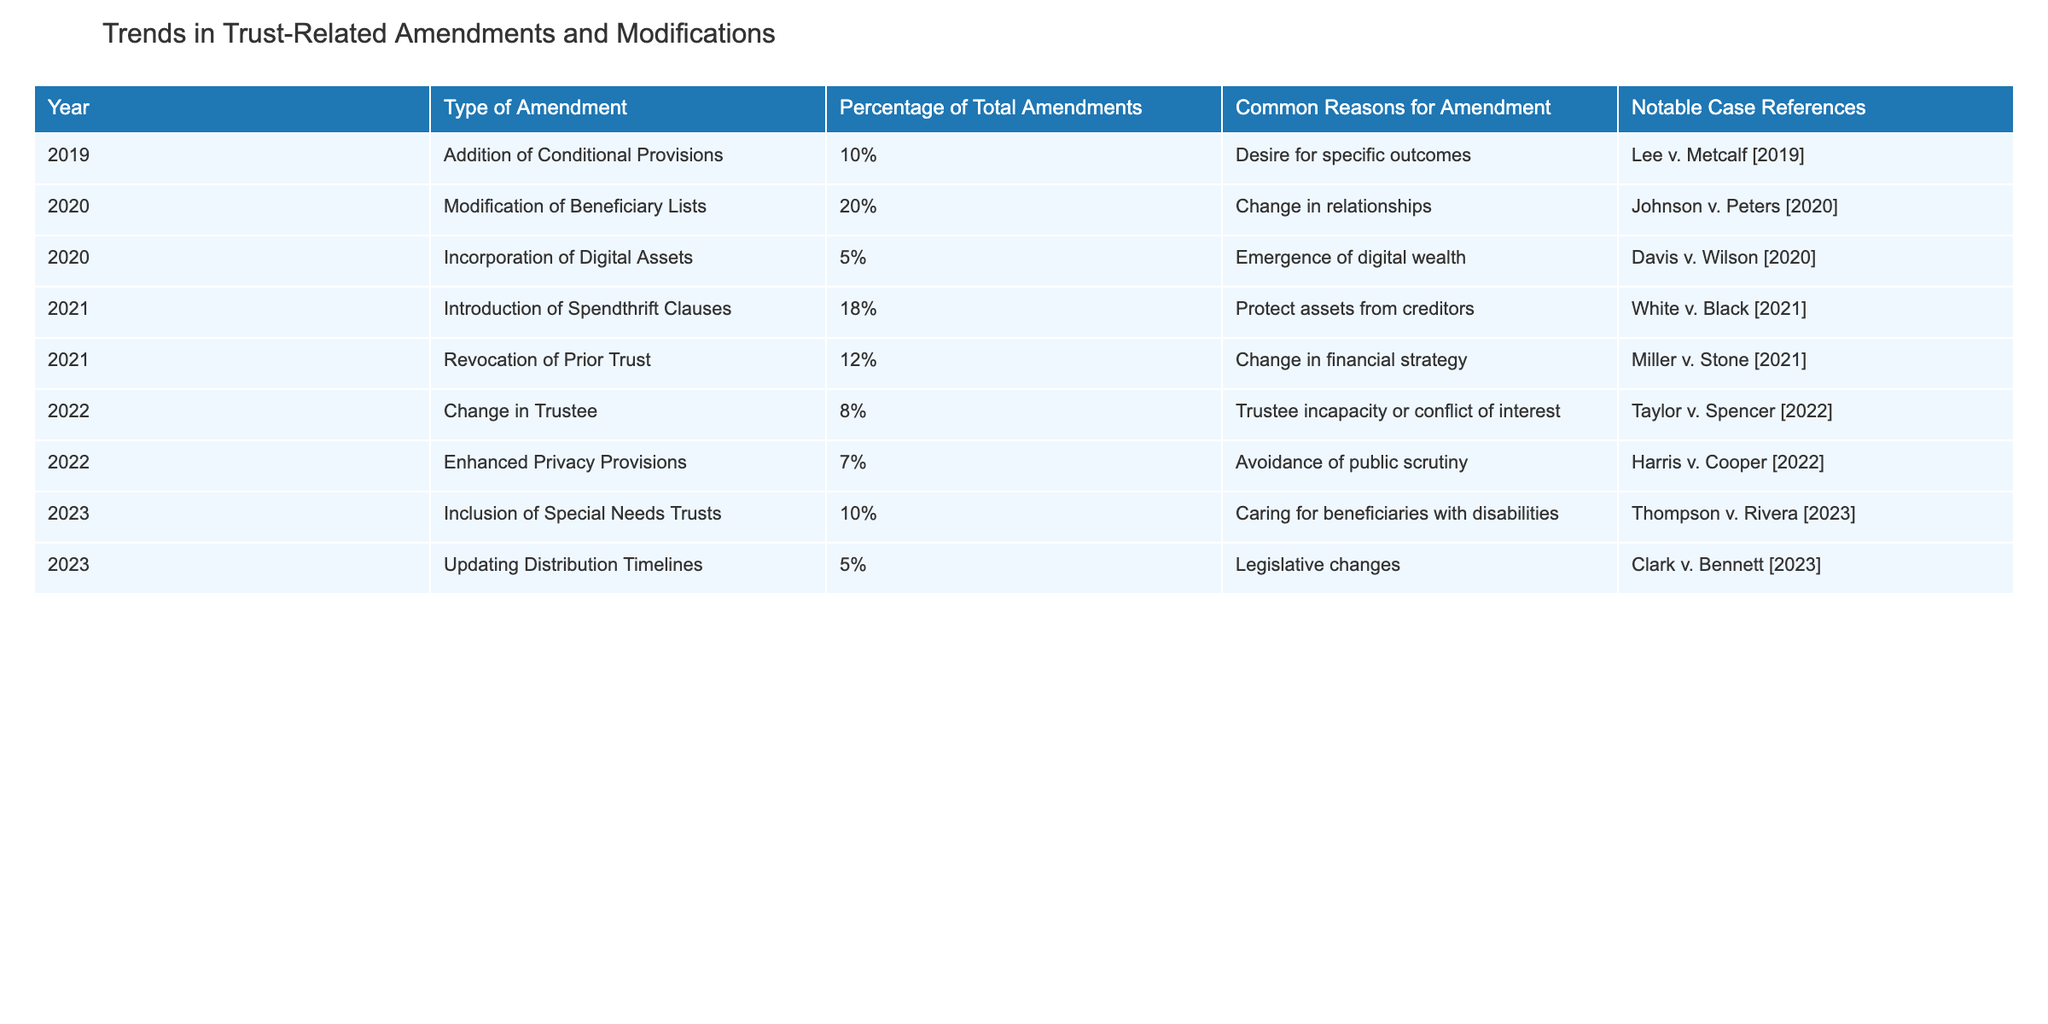What was the most common type of amendment in 2020? The table indicates that in 2020, the most common type of amendment was the "Modification of Beneficiary Lists," which accounted for 20% of total amendments.
Answer: Modification of Beneficiary Lists How many types of amendments were made in 2021? In 2021, there were two types of amendments listed: "Introduction of Spendthrift Clauses" and "Revocation of Prior Trust."
Answer: 2 What is the percentage of total amendments that involved the addition of Conditional Provisions from 2019 to 2023? The table shows that in 2019, 10% of total amendments involved the addition of Conditional Provisions. There are no records of this amendment from 2020 to 2023, so the total is still 10%.
Answer: 10% Was there any amendment related to digital assets in 2021? The table does not list any amendments related to digital assets in 2021. The only mention of digital assets comes from 2020, which shows that 5% of amendments were related to the incorporation of digital assets.
Answer: No What is the total percentage of amendments marked for protecting assets from creditors and caring for beneficiaries with disabilities? The "Introduction of Spendthrift Clauses" in 2021 (18%) and "Inclusion of Special Needs Trusts" in 2023 (10%) both aim to protect beneficiaries. Summing these, we get 18% + 10% = 28%.
Answer: 28% 